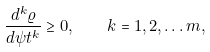Convert formula to latex. <formula><loc_0><loc_0><loc_500><loc_500>\frac { d ^ { k } \varrho } { d \psi t ^ { k } } \geq 0 , \quad k = 1 , 2 , \dots m ,</formula> 